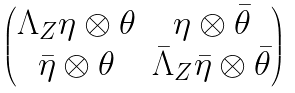Convert formula to latex. <formula><loc_0><loc_0><loc_500><loc_500>\begin{pmatrix} \Lambda _ { Z } \eta \otimes \theta & \eta \otimes \bar { \theta } \\ \bar { \eta } \otimes \theta & \bar { \Lambda } _ { Z } \bar { \eta } \otimes \bar { \theta } \end{pmatrix}</formula> 